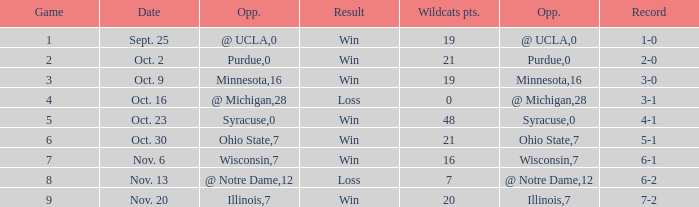What game number did the Wildcats play Purdue? 2.0. Parse the table in full. {'header': ['Game', 'Date', 'Opp.', 'Result', 'Wildcats pts.', 'Opp.', 'Record'], 'rows': [['1', 'Sept. 25', '@ UCLA', 'Win', '19', '0', '1-0'], ['2', 'Oct. 2', 'Purdue', 'Win', '21', '0', '2-0'], ['3', 'Oct. 9', 'Minnesota', 'Win', '19', '16', '3-0'], ['4', 'Oct. 16', '@ Michigan', 'Loss', '0', '28', '3-1'], ['5', 'Oct. 23', 'Syracuse', 'Win', '48', '0', '4-1'], ['6', 'Oct. 30', 'Ohio State', 'Win', '21', '7', '5-1'], ['7', 'Nov. 6', 'Wisconsin', 'Win', '16', '7', '6-1'], ['8', 'Nov. 13', '@ Notre Dame', 'Loss', '7', '12', '6-2'], ['9', 'Nov. 20', 'Illinois', 'Win', '20', '7', '7-2']]} 